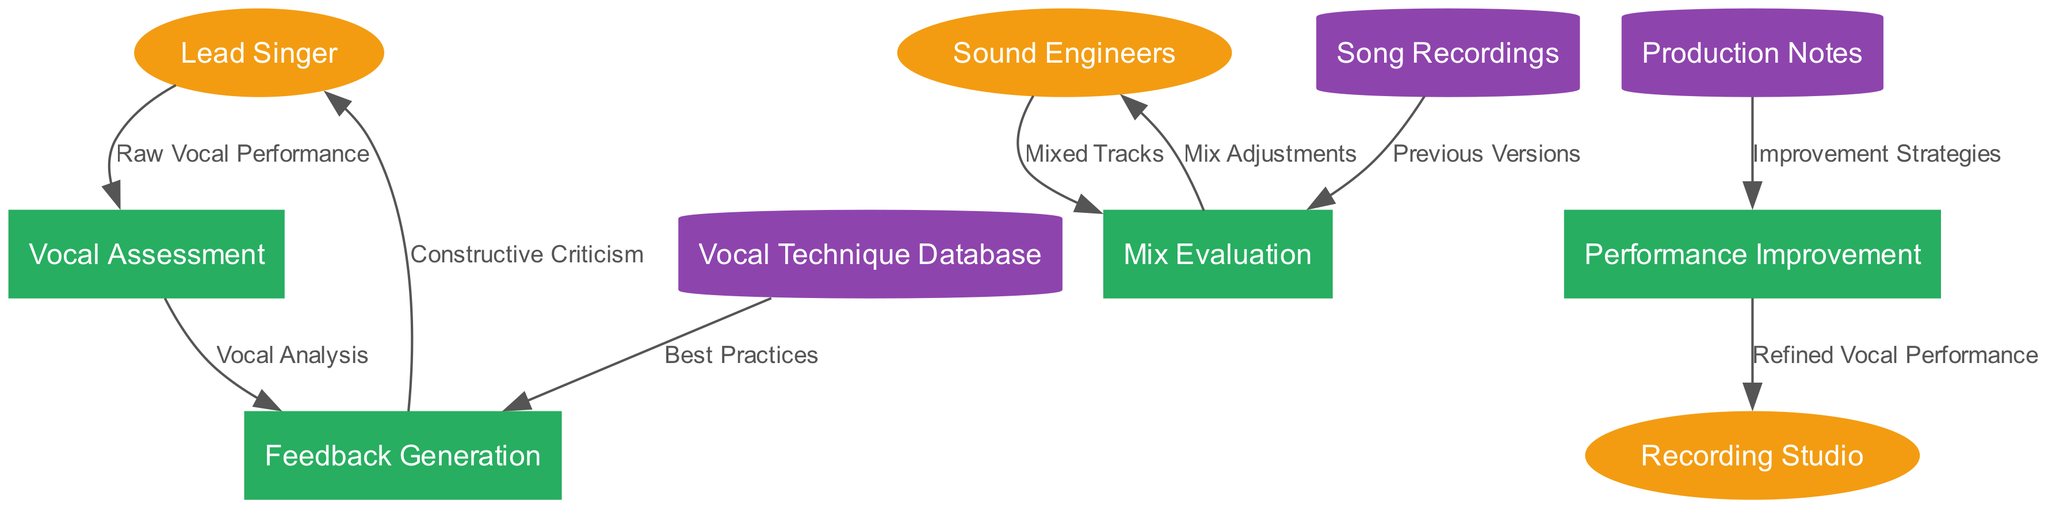What are the external entities in the diagram? The external entities include the Lead Singer, Sound Engineers, and Recording Studio. These are represented as ellipse shapes in the diagram, indicating their role as external sources or consumers of data.
Answer: Lead Singer, Sound Engineers, Recording Studio How many processes are depicted in the diagram? There are four processes shown in the diagram: Vocal Assessment, Feedback Generation, Mix Evaluation, and Performance Improvement. The counting of process nodes provides the total number of processes in the diagram.
Answer: Four Which process generates constructive criticism? The process that generates constructive criticism is the Feedback Generation. This is indicated by the data flow from the Feedback Generation process to the Lead Singer labeled as "Constructive Criticism."
Answer: Feedback Generation What type of data flow is between Vocal Assessment and Feedback Generation? The data flow from Vocal Assessment to Feedback Generation is labeled as "Vocal Analysis." This indicates that the analysis from the Vocal Assessment informs feedback generation.
Answer: Vocal Analysis What data store provides best practices to the Feedback Generation process? The data store that provides best practices to the Feedback Generation process is the Vocal Technique Database. This indicates a flow of information from the database to the feedback process.
Answer: Vocal Technique Database How many data stores are connected to the Performance Improvement process? Three data stores are connected to the Performance Improvement process: Production Notes, Vocal Technique Database, and Song Recordings. Analyzing the connections shows that these three data stores supply information related to performance improvement strategies.
Answer: Three Which process sends refined vocal performances to the Recording Studio? The process that sends refined vocal performances to the Recording Studio is Performance Improvement. This is shown in the diagram as a data flow from Performance Improvement to the Recording Studio.
Answer: Performance Improvement What input does the Vocal Assessment process receive? The Vocal Assessment process receives "Raw Vocal Performance" as input from the Lead Singer. This flow signifies the initial data provided for vocal assessment.
Answer: Raw Vocal Performance Which external entity receives mix adjustments? The Sound Engineers receive mix adjustments as indicated by the data flow from the Mix Evaluation process back to Sound Engineers, showing that adjustments are communicated to them for refining tracks.
Answer: Sound Engineers 